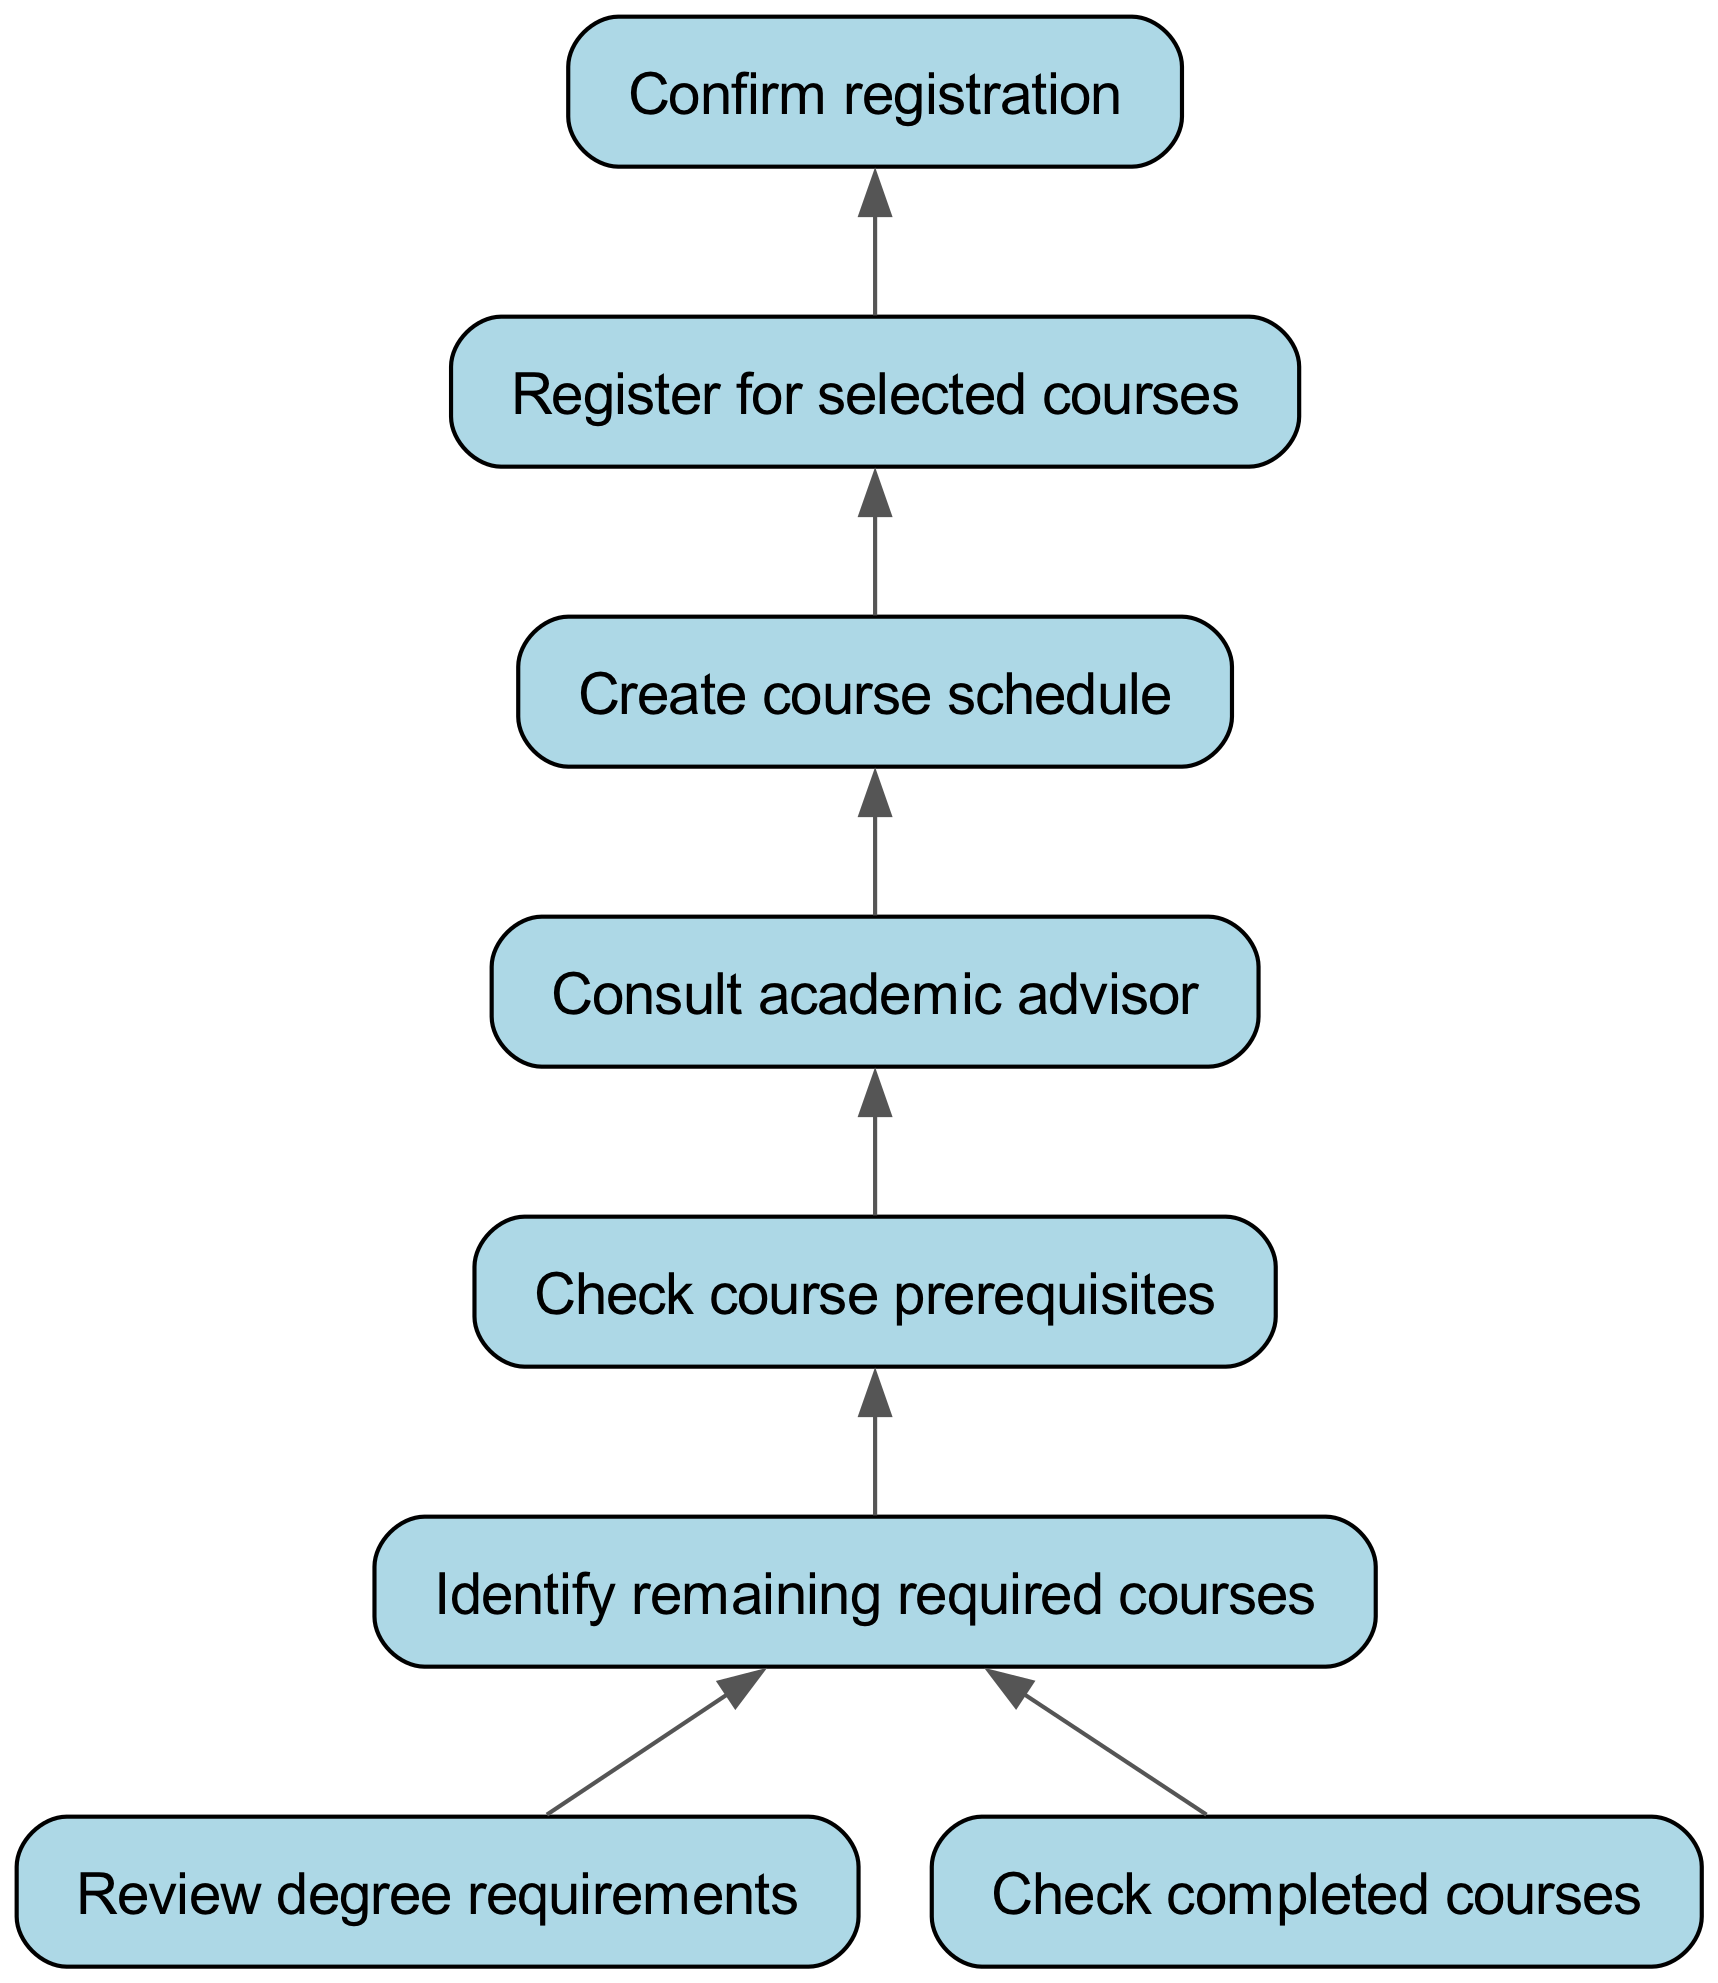What is the first step in the course selection process? The first step is to "Review degree requirements", which is represented as the initial node at the bottom of the flow chart.
Answer: Review degree requirements How many nodes are in the diagram? By counting the distinct elements listed in the data, we find there are eight nodes: Review degree requirements, Check completed courses, Identify remaining required courses, Check course prerequisites, Consult academic advisor, Create course schedule, Register for selected courses, and Confirm registration.
Answer: Eight Which step comes after checking course prerequisites? The step following "Check course prerequisites" is "Consult academic advisor", which is the next node connected from that point.
Answer: Consult academic advisor What do you do after creating a course schedule? After "Create course schedule", the next action is to "Register for selected courses", which is indicated by the edge connecting those two nodes.
Answer: Register for selected courses Which two steps are directly related to reviewing degree requirements? The two steps that follow from "Review degree requirements" are "Identify remaining required courses" and "Check completed courses". Both nodes are directly connected to it.
Answer: Identify remaining required courses, Check completed courses What is the relationship between checking completed courses and identifying remaining required courses? Both "Check completed courses" and "Review degree requirements" lead to "Identify remaining required courses", establishing that completed courses help in recognizing what still needs to be taken.
Answer: Leads to What is the last step in the course selection process? The final step in the flow chart is "Confirm registration", which is the last node that concludes the entire process.
Answer: Confirm registration How many edges connect the nodes in the diagram? To determine the edges, we can count the connections outlined in the data — there are seven edges connecting the eight nodes.
Answer: Seven Which step must be completed before registering for selected courses? The step that must precede "Register for selected courses" is "Create course schedule", which has a directional connection leading to the registration process.
Answer: Create course schedule 